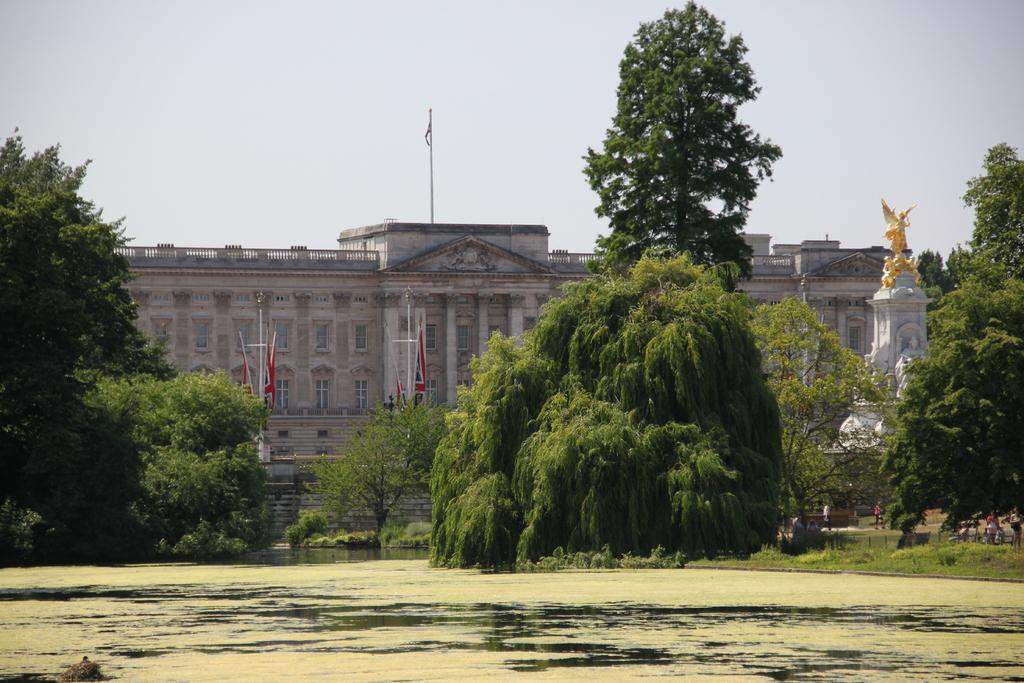What body of water is visible in the image? There is a lake in the image. What is located behind the lake? There is a building behind the lake. What type of vegetation is present around the lake? Trees and plants are present around the lake. What can be seen flying or waving in the image? There are flags in the image. What type of structure is located to the side of the lake? There is a statue to the side of the lake. How does the self help with the cherries in the image? There is no self or cherries present in the image. What type of assistance can be provided by the help in the image? There is no help present in the image; it is a scene featuring a lake, a building, trees, plants, flags, and a statue. 